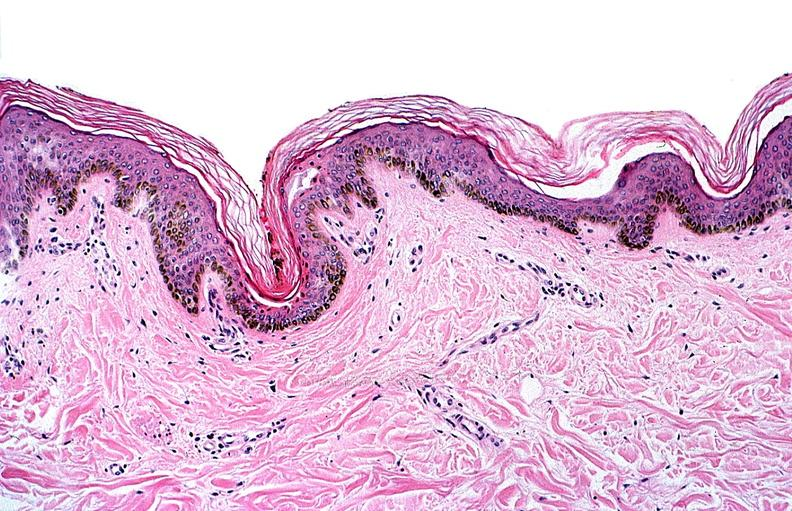does omphalocele show thermal burned skin?
Answer the question using a single word or phrase. No 